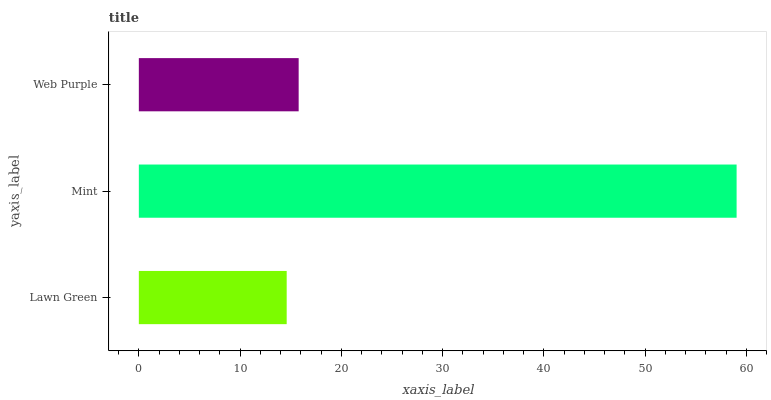Is Lawn Green the minimum?
Answer yes or no. Yes. Is Mint the maximum?
Answer yes or no. Yes. Is Web Purple the minimum?
Answer yes or no. No. Is Web Purple the maximum?
Answer yes or no. No. Is Mint greater than Web Purple?
Answer yes or no. Yes. Is Web Purple less than Mint?
Answer yes or no. Yes. Is Web Purple greater than Mint?
Answer yes or no. No. Is Mint less than Web Purple?
Answer yes or no. No. Is Web Purple the high median?
Answer yes or no. Yes. Is Web Purple the low median?
Answer yes or no. Yes. Is Mint the high median?
Answer yes or no. No. Is Mint the low median?
Answer yes or no. No. 